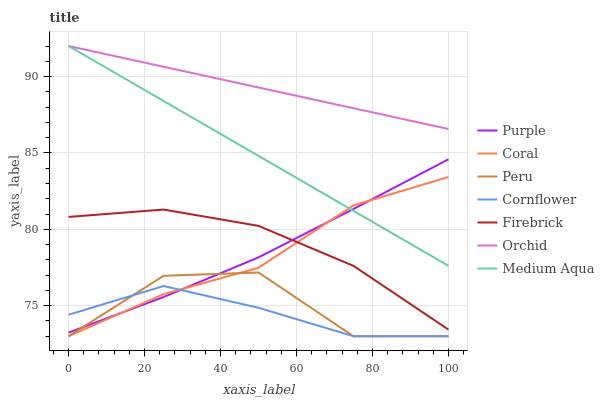Does Cornflower have the minimum area under the curve?
Answer yes or no. Yes. Does Orchid have the maximum area under the curve?
Answer yes or no. Yes. Does Purple have the minimum area under the curve?
Answer yes or no. No. Does Purple have the maximum area under the curve?
Answer yes or no. No. Is Orchid the smoothest?
Answer yes or no. Yes. Is Peru the roughest?
Answer yes or no. Yes. Is Purple the smoothest?
Answer yes or no. No. Is Purple the roughest?
Answer yes or no. No. Does Purple have the lowest value?
Answer yes or no. No. Does Orchid have the highest value?
Answer yes or no. Yes. Does Purple have the highest value?
Answer yes or no. No. Is Firebrick less than Orchid?
Answer yes or no. Yes. Is Orchid greater than Firebrick?
Answer yes or no. Yes. Does Peru intersect Cornflower?
Answer yes or no. Yes. Is Peru less than Cornflower?
Answer yes or no. No. Is Peru greater than Cornflower?
Answer yes or no. No. Does Firebrick intersect Orchid?
Answer yes or no. No. 